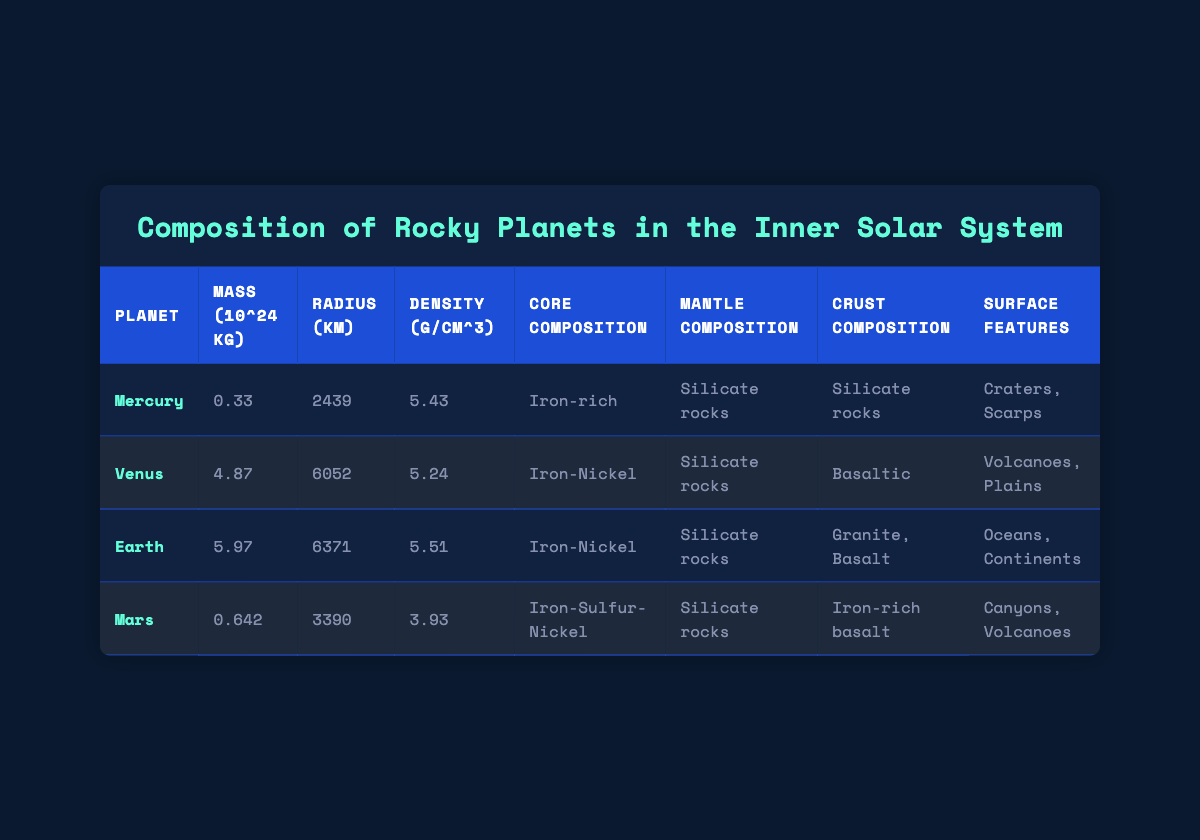What is the mass of Venus? The table lists the mass of Venus as 4.87 (10^24 kg) directly under the "Mass (10^24 kg)" column.
Answer: 4.87 Which planet has the highest density? The density values provided show Earth as having a density of 5.51 g/cm^3, which is higher than the densities of Mercury, Venus, and Mars.
Answer: Earth Is the core composition of Mars mainly Iron? The table indicates that Mars has a core composition of Iron-Sulfur-Nickel, which includes Iron. Therefore, it is true that Iron is a significant component in Mars' core.
Answer: Yes What is the average radius of the rocky planets in the inner Solar System? The radii of Mercury (2439 km), Venus (6052 km), Earth (6371 km), and Mars (3390 km) can be summed up: 2439 + 6052 + 6371 + 3390 = 18252 km. Dividing this sum by 4 gives the average radius as 18252 / 4 = 4563 km.
Answer: 4563 km What surface features does Mars have compared to Earth? The table indicates that Mars has canyons and volcanoes as surface features, while Earth has oceans and continents. This provides a contrast in the types of surface features between the two planets.
Answer: Canyons; Volcanoes Which rocky planet is the smallest in radius? The radius values show that Mercury has the smallest radius of 2439 km when compared to Venus, Earth, and Mars.
Answer: Mercury Does Venus have a crust composition of Granite? The table states that Venus has a crust composition of Basaltic, not Granite, making this statement false.
Answer: No What planet has the lowest density and what is that density? By comparing the density values, Mars has the lowest density at 3.93 g/cm^3. This can be confirmed as it is lower than the densities listed for the other planets.
Answer: Mars; 3.93 g/cm^3 Which rocky planet has Volcanoes as a surface feature? The table shows that both Venus and Mars have Volcanoes listed as surface features, indicating both planets have this geological characteristic.
Answer: Venus; Mars If we compare the core compositions, how many planets have Iron in their core composition? By examining the core compositions, Mercury (Iron-rich), Venus (Iron-Nickel), and Mars (Iron-Sulfur-Nickel) all contain Iron, making it a total of three planets.
Answer: Three planets 